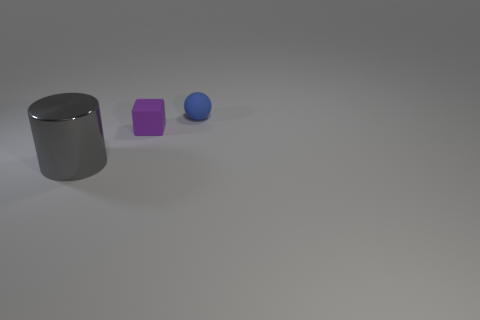Add 2 purple rubber blocks. How many objects exist? 5 Subtract all spheres. How many objects are left? 2 Add 3 balls. How many balls exist? 4 Subtract 1 purple blocks. How many objects are left? 2 Subtract all matte balls. Subtract all small purple matte cubes. How many objects are left? 1 Add 3 purple objects. How many purple objects are left? 4 